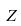Convert formula to latex. <formula><loc_0><loc_0><loc_500><loc_500>Z</formula> 